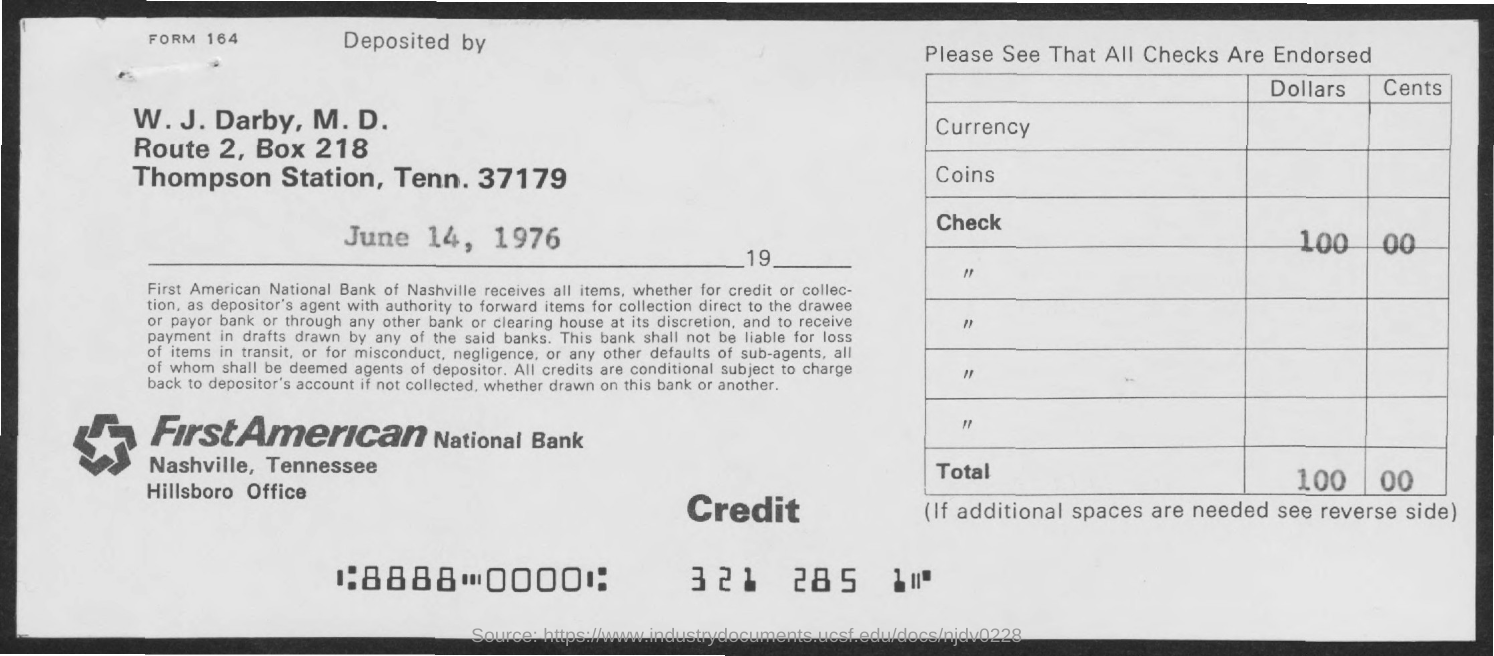Who has deposited the check amount?
Offer a very short reply. W. J. Darby, M. D. What is the deposit date given in the form?
Make the answer very short. June 14, 1976. 